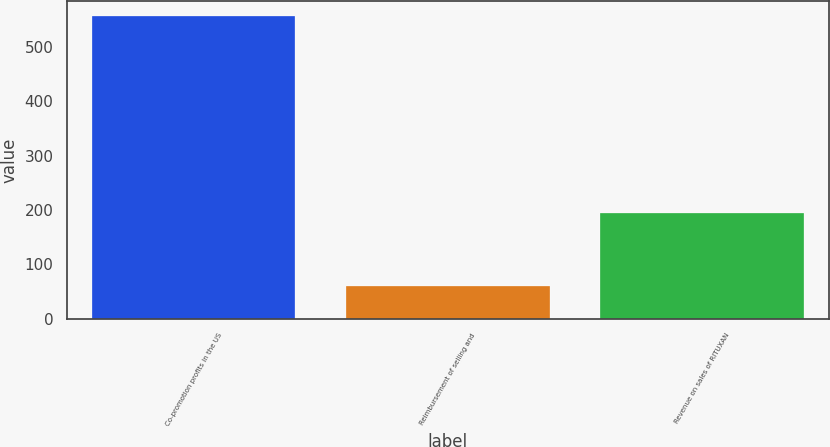Convert chart to OTSL. <chart><loc_0><loc_0><loc_500><loc_500><bar_chart><fcel>Co-promotion profits in the US<fcel>Reimbursement of selling and<fcel>Revenue on sales of RITUXAN<nl><fcel>555.8<fcel>61.1<fcel>194<nl></chart> 